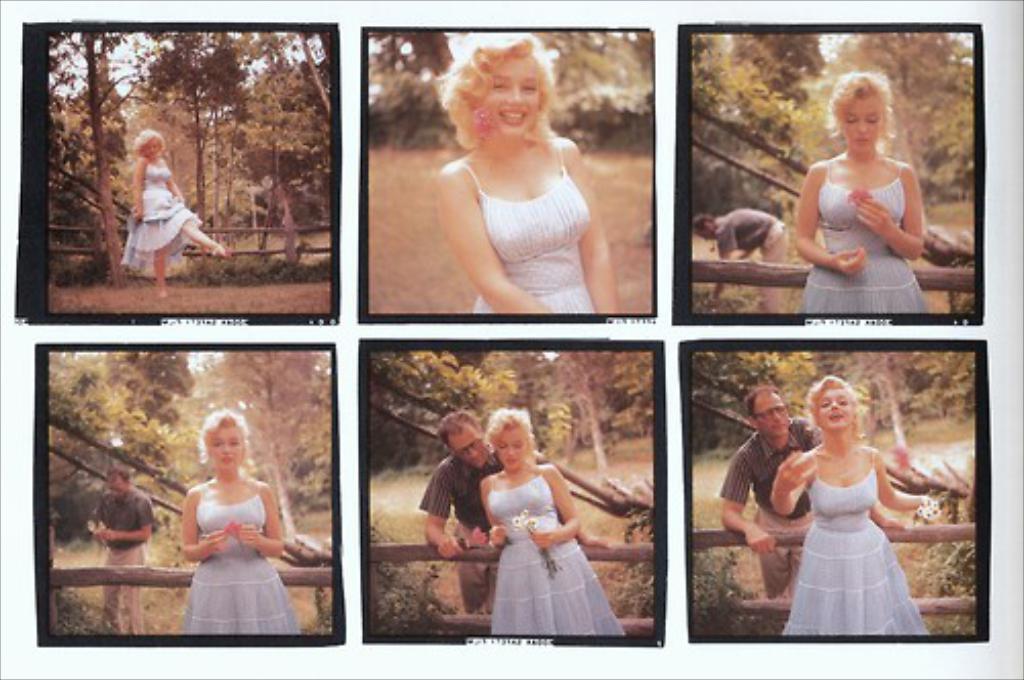How would you summarize this image in a sentence or two? There is a collage image of different pictures. There is a only person presenting in first three pictures. There are two persons presenting in last three pictures. 